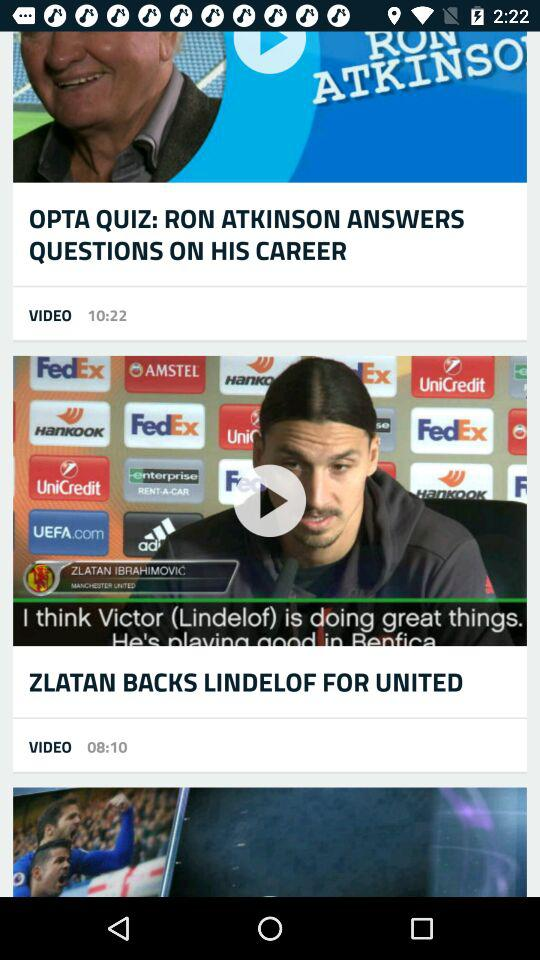On which date was the "ZLATAN BACKS LINDELOF FOR UNITED" article posted?
When the provided information is insufficient, respond with <no answer>. <no answer> 